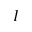Convert formula to latex. <formula><loc_0><loc_0><loc_500><loc_500>I</formula> 